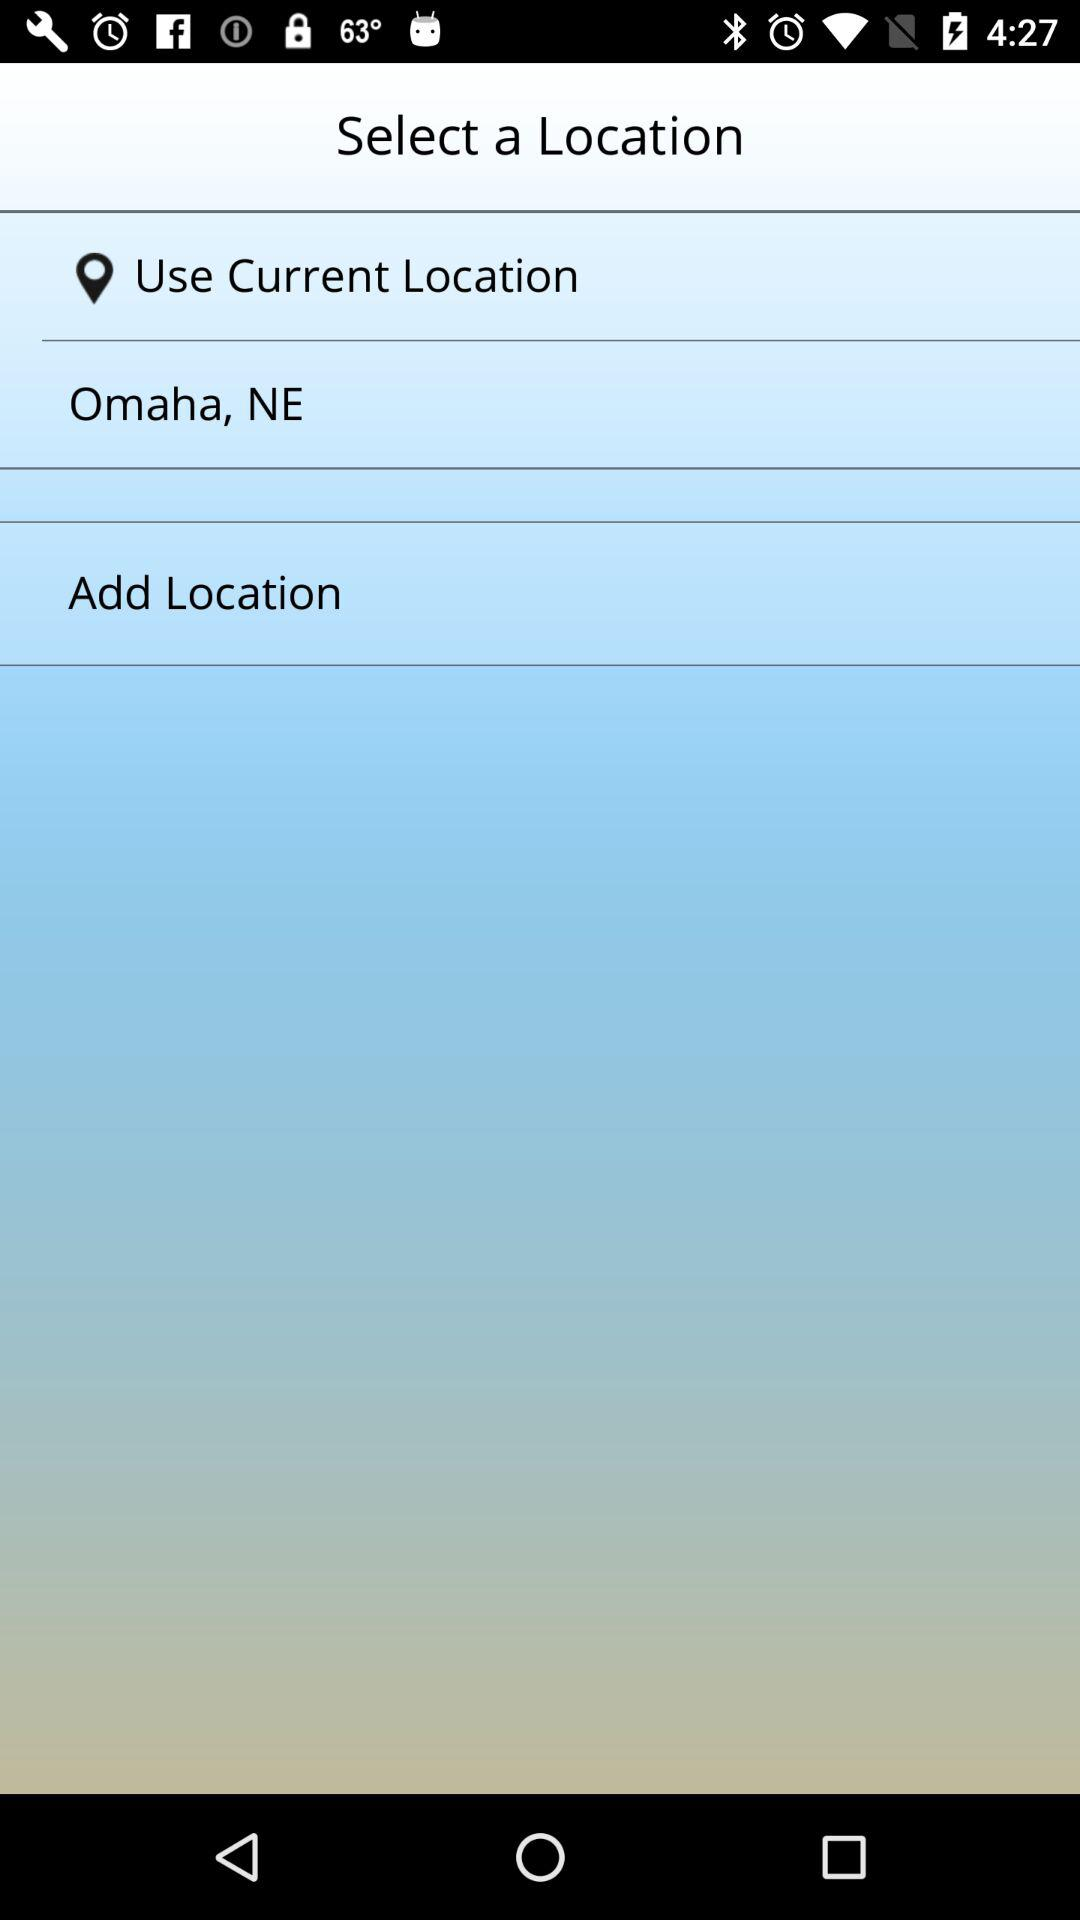Which city location is added?
When the provided information is insufficient, respond with <no answer>. <no answer> 